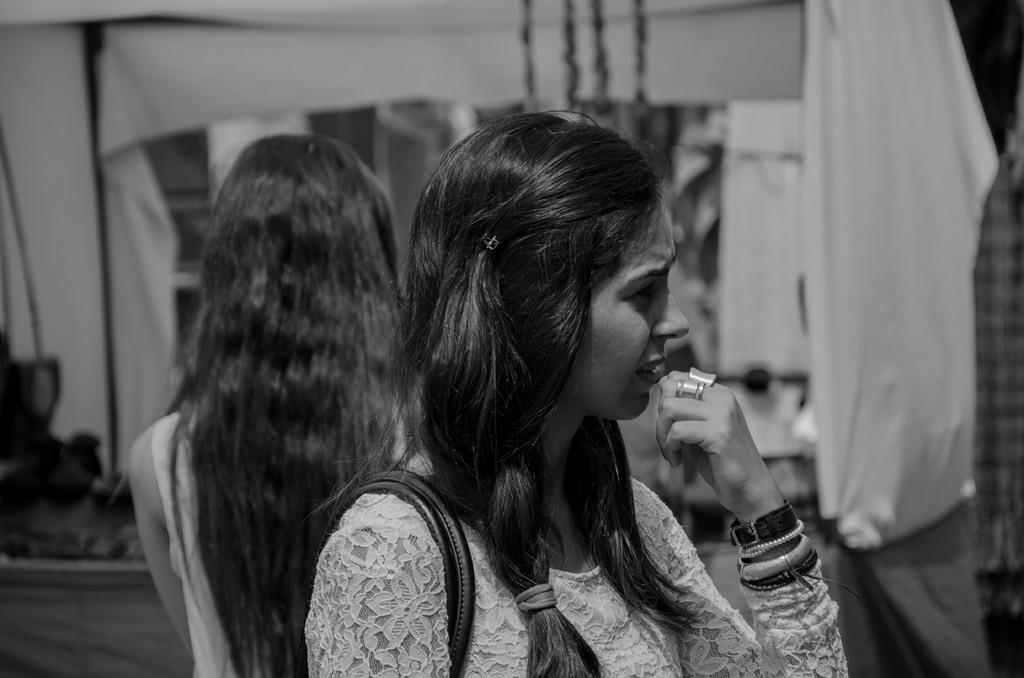Who is the main subject in the image? There is a lady in the image. What is the lady wearing on her hand? The lady is wearing bands on her hand. Can you describe the background of the image? There is another lady in the background of the image. What else can be seen in the image besides the ladies? There are other things visible in the image. What type of crime is being committed by the ants in the image? There are no ants present in the image, so it is not possible to determine if a crime is being committed by them. 